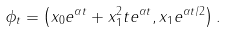<formula> <loc_0><loc_0><loc_500><loc_500>\phi _ { t } = \left ( x _ { 0 } e ^ { \alpha t } + x _ { 1 } ^ { 2 } t e ^ { \alpha t } , x _ { 1 } e ^ { \alpha t / 2 } \right ) .</formula> 